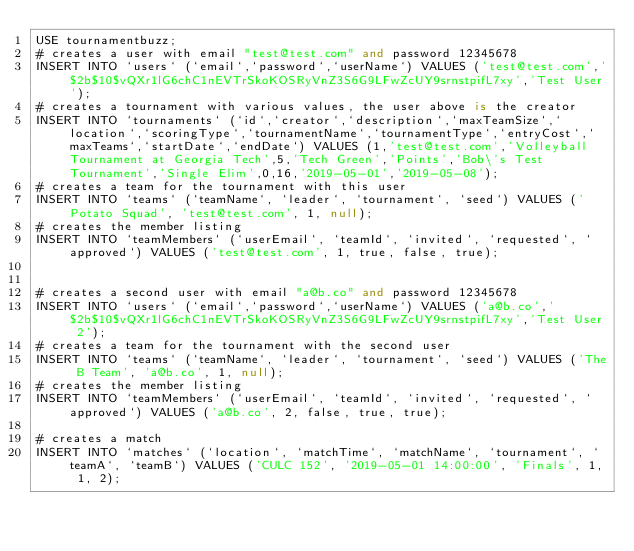Convert code to text. <code><loc_0><loc_0><loc_500><loc_500><_SQL_>USE tournamentbuzz;
# creates a user with email "test@test.com" and password 12345678
INSERT INTO `users` (`email`,`password`,`userName`) VALUES ('test@test.com','$2b$10$vQXr1lG6chC1nEVTrSkoKOSRyVnZ3S6G9LFwZcUY9srnstpifL7xy','Test User');
# creates a tournament with various values, the user above is the creator
INSERT INTO `tournaments` (`id`,`creator`,`description`,`maxTeamSize`,`location`,`scoringType`,`tournamentName`,`tournamentType`,`entryCost`,`maxTeams`,`startDate`,`endDate`) VALUES (1,'test@test.com','Volleyball Tournament at Georgia Tech',5,'Tech Green','Points','Bob\'s Test Tournament','Single Elim',0,16,'2019-05-01','2019-05-08');
# creates a team for the tournament with this user
INSERT INTO `teams` (`teamName`, `leader`, `tournament`, `seed`) VALUES ('Potato Squad', 'test@test.com', 1, null);
# creates the member listing
INSERT INTO `teamMembers` (`userEmail`, `teamId`, `invited`, `requested`, `approved`) VALUES ('test@test.com', 1, true, false, true);


# creates a second user with email "a@b.co" and password 12345678
INSERT INTO `users` (`email`,`password`,`userName`) VALUES ('a@b.co','$2b$10$vQXr1lG6chC1nEVTrSkoKOSRyVnZ3S6G9LFwZcUY9srnstpifL7xy','Test User 2');
# creates a team for the tournament with the second user
INSERT INTO `teams` (`teamName`, `leader`, `tournament`, `seed`) VALUES ('The B Team', 'a@b.co', 1, null);
# creates the member listing
INSERT INTO `teamMembers` (`userEmail`, `teamId`, `invited`, `requested`, `approved`) VALUES ('a@b.co', 2, false, true, true);

# creates a match
INSERT INTO `matches` (`location`, `matchTime`, `matchName`, `tournament`, `teamA`, `teamB`) VALUES ('CULC 152', '2019-05-01 14:00:00', 'Finals', 1, 1, 2);
</code> 